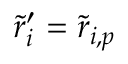Convert formula to latex. <formula><loc_0><loc_0><loc_500><loc_500>\tilde { r } _ { i } ^ { \prime } = \tilde { r } _ { i , p }</formula> 